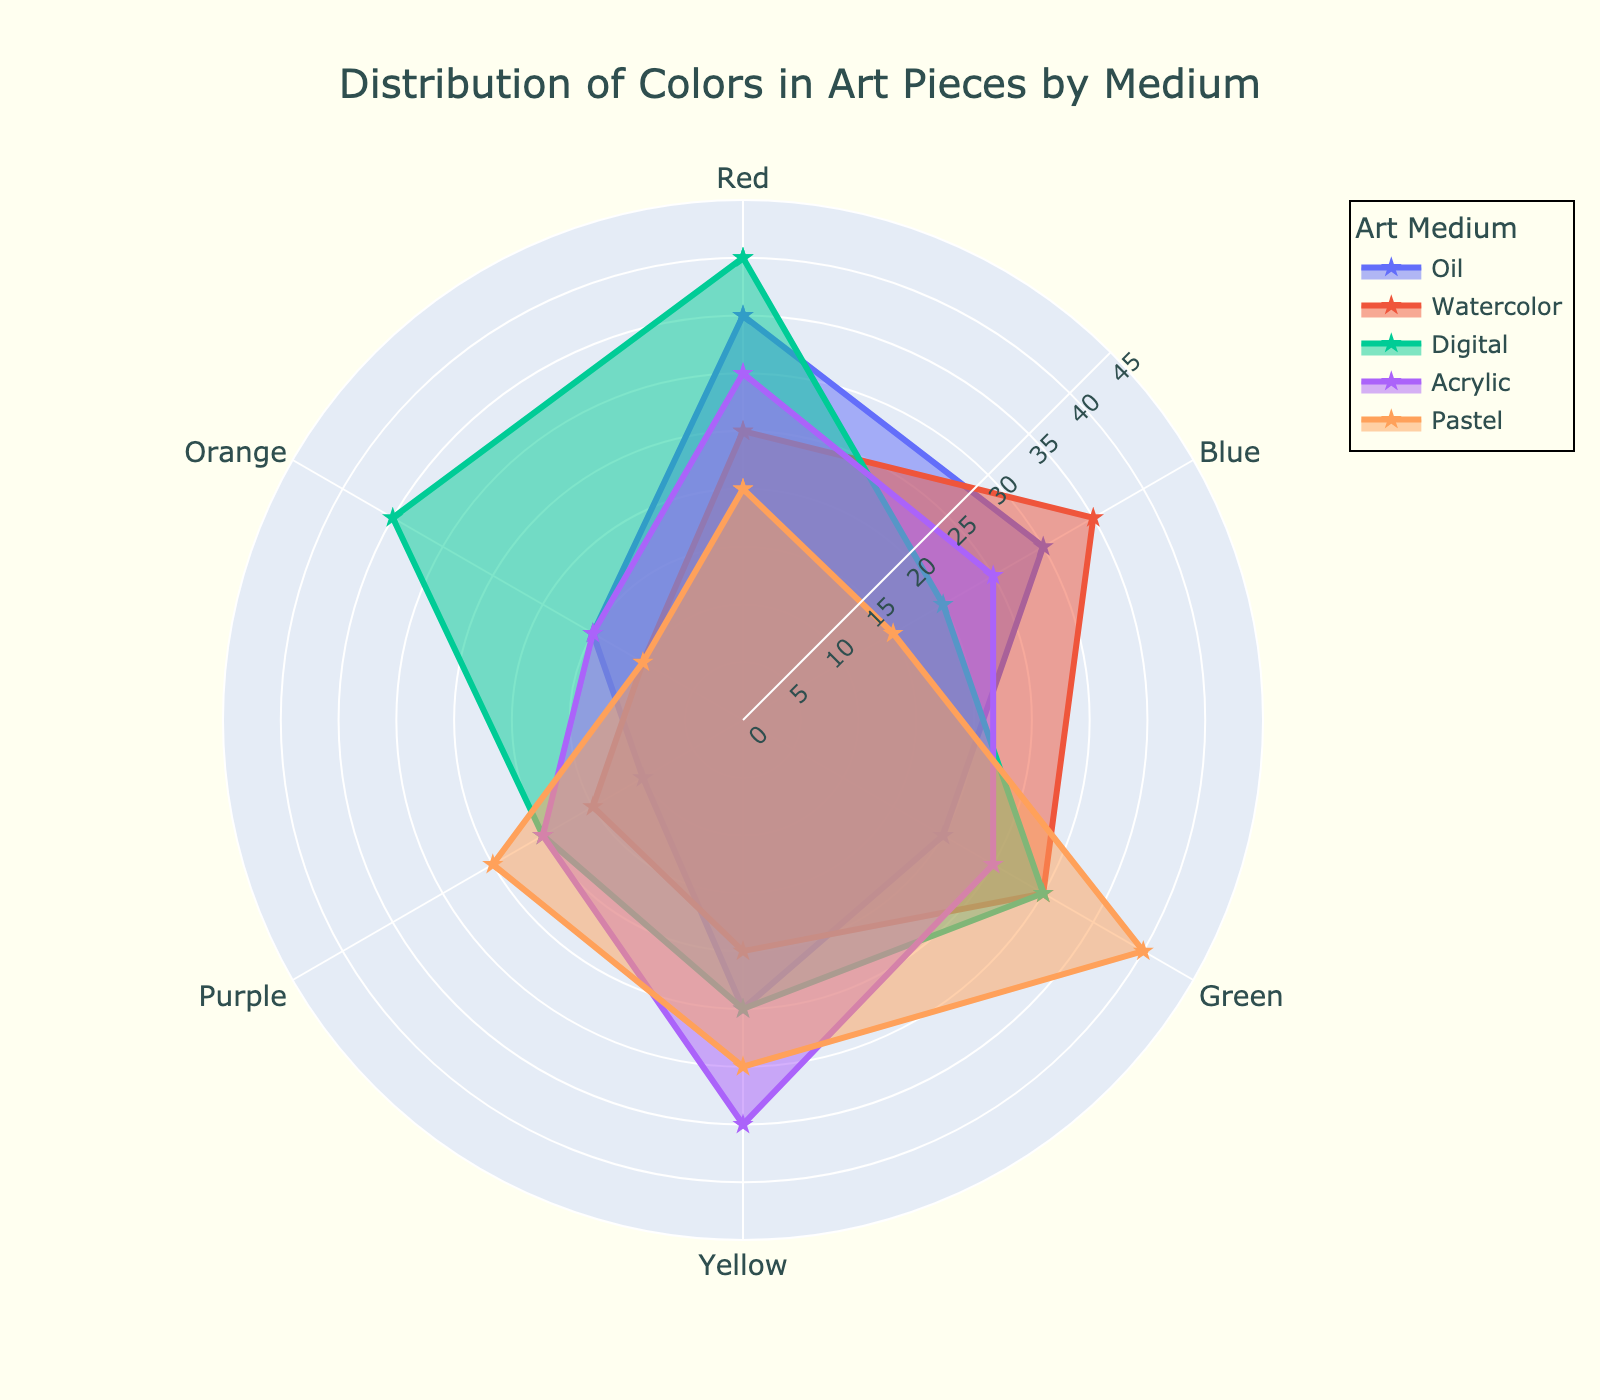Which art medium has the highest usage of Red in their pieces? By looking at the radial axis for the 'Red' category and comparing the values for each art medium, we see that the Digital medium has the highest value (40).
Answer: Digital What is the average usage of Blue across all art mediums? Summing up the Blue values: 30 (Oil) + 35 (Watercolor) + 20 (Digital) + 25 (Acrylic) + 15 (Pastel) = 125. Dividing by the number of mediums (5) gives 125 / 5 = 25.
Answer: 25 Which two art mediums have the closest distribution for Green? Comparing the values for Green across the mediums: Oil (20), Watercolor (30), Digital (30), Acrylic (25), and Pastel (40). Watercolor and Digital both have a value of 30, which is the same.
Answer: Watercolor and Digital How much more Yellow is used in Pastel compared to Oil? Yellow in Pastel (30) minus Yellow in Oil (25) = 30 - 25 = 5.
Answer: 5 Which medium uses the least amount of Purple? By comparing the values for Purple, the lowest value is for Oil (10).
Answer: Oil What is the sum of all color values for Acrylic? Summing up all the color values for Acrylic: 30 (Red) + 25 (Blue) + 25 (Green) + 35 (Yellow) + 20 (Purple) + 15 (Orange) = 150.
Answer: 150 Is there any medium that uses equal amounts of two different colors? If yes, which medium and colors? By examining the values, Oil uses equally Red (35) and Blue (35).
Answer: Oil, Red and Blue In which art medium is the usage of Orange the highest? Looking at the values for Orange, Digital has the highest value (35).
Answer: Digital What is the difference between the maximum and minimum usage values of Green across all mediums? The highest value for Green is 40 (Pastel) and the lowest is 20 (Oil). The difference is 40 - 20 = 20.
Answer: 20 How does the distribution pattern for Watercolor compare to Acrylic in terms of overall balance across all colors? Watercolor's values are 25 (Red), 35 (Blue), 30 (Green), 20 (Yellow), 15 (Purple), 10 (Orange) and Acrylic's values are 30 (Red), 25 (Blue), 25 (Green), 35 (Yellow), 20 (Purple), 15 (Orange). Both mediums show a varied distribution across colors but Watercolor has a more uneven spread with higher contrasts whereas Acrylic distribution values are more balanced overall.
Answer: Watercolor has a more uneven distribution compared to Acrylic 